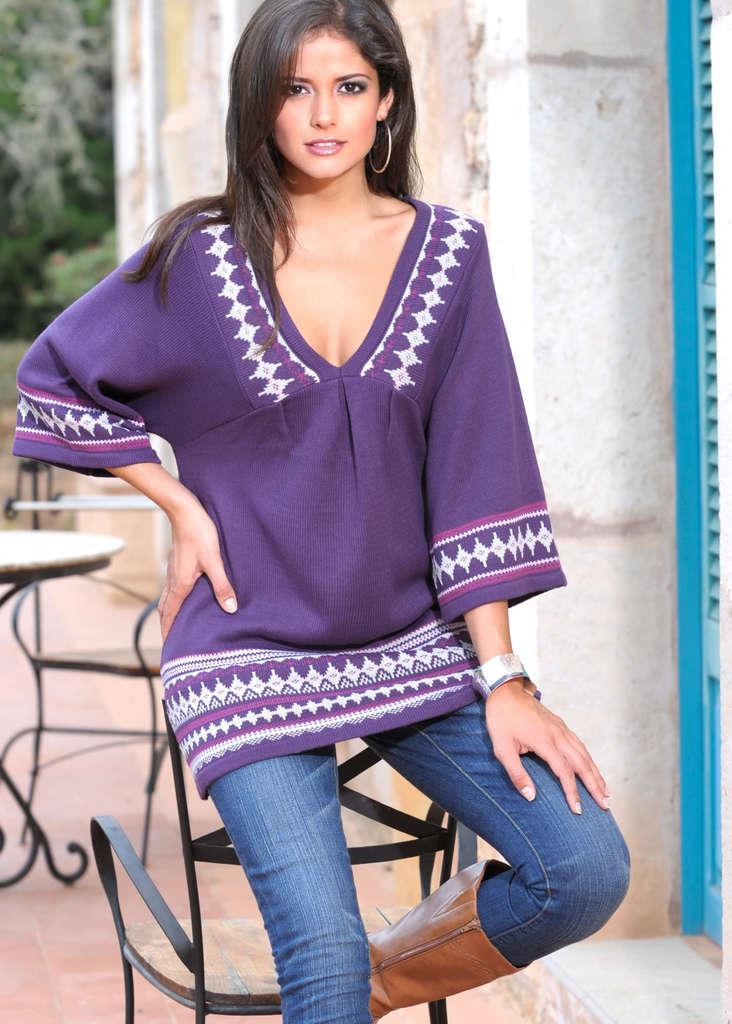In one or two sentences, can you explain what this image depicts? In this image I can see a woman, I can see she is wearing purple colour top, blue jeans and brown shoe. In background I can see few chairs, a table, a tree and I can see this image is little bit blurry from background. 